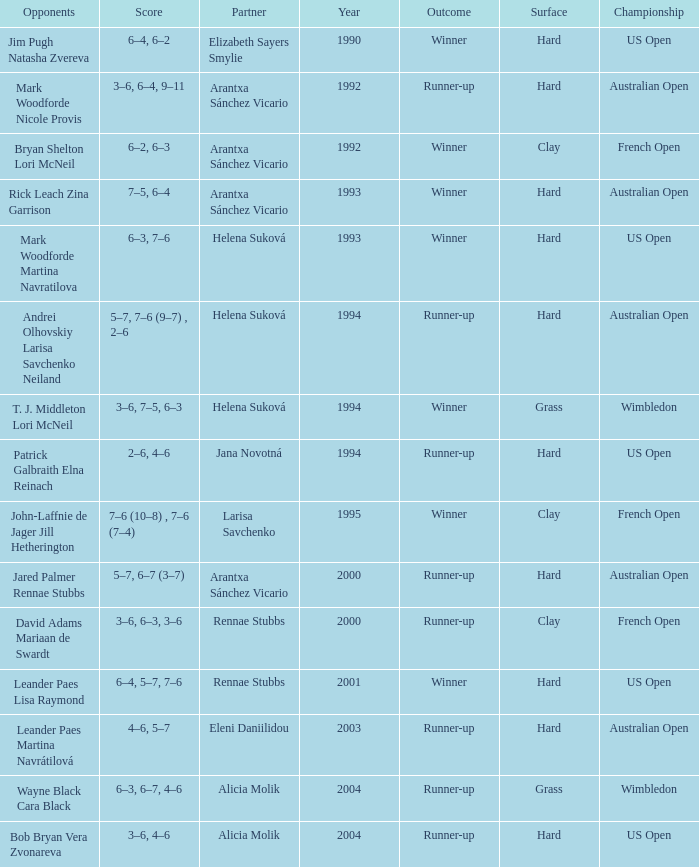Who was the Partner that was a winner, a Year smaller than 1993, and a Score of 6–4, 6–2? Elizabeth Sayers Smylie. 